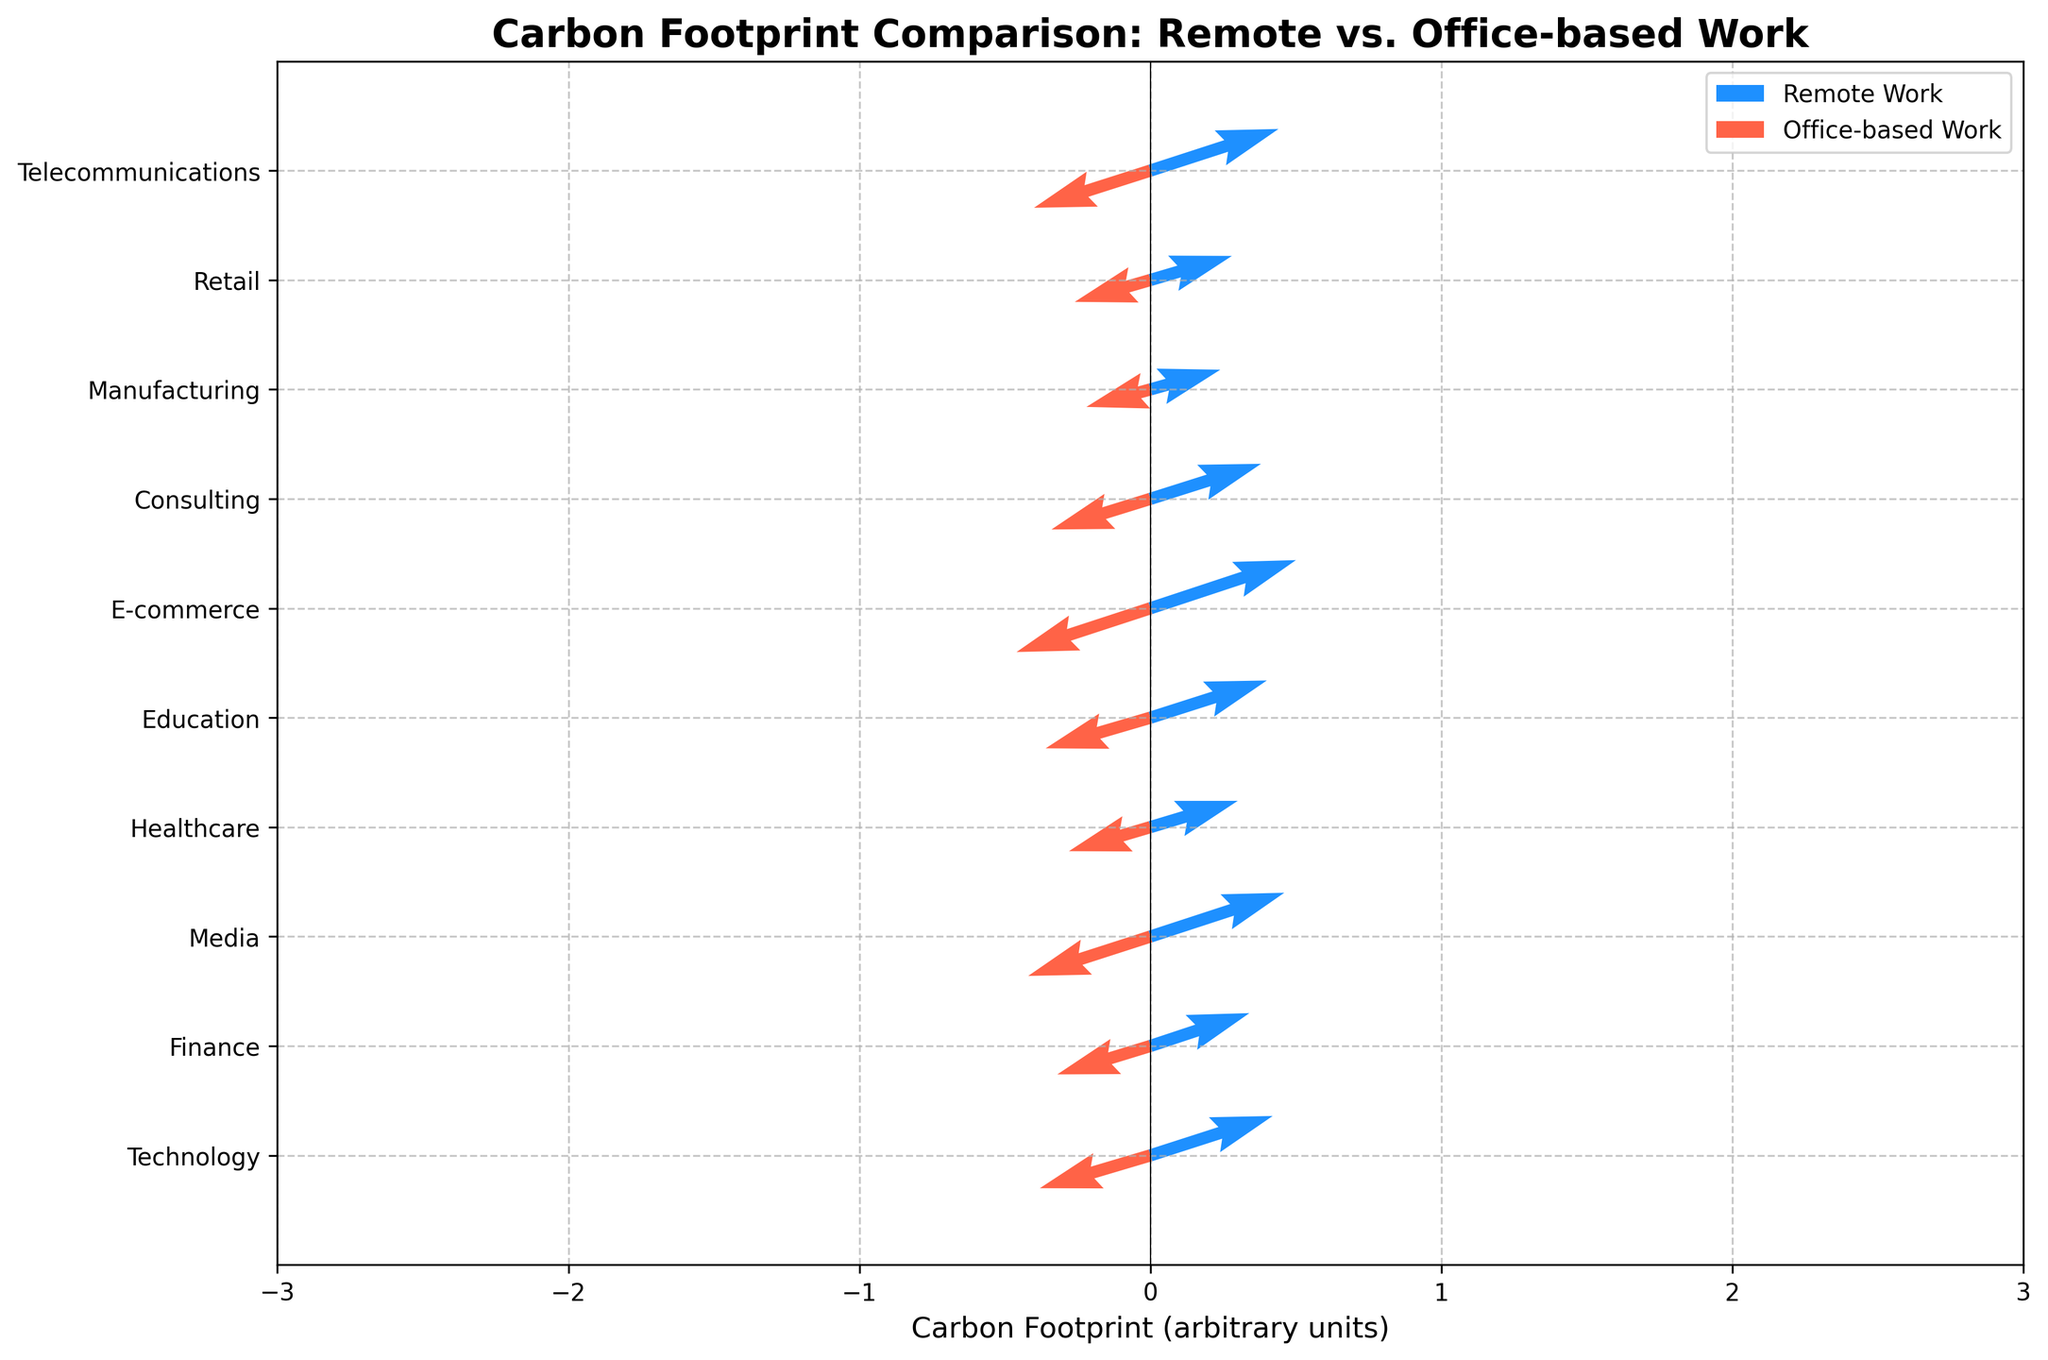What does the title of the figure indicate? The title of the figure reads "Carbon Footprint Comparison: Remote vs. Office-based Work," which indicates that the figure compares the carbon footprint associated with remote work versus office-based work across various industries.
Answer: Carbon Footprint Comparison: Remote vs. Office-based Work How can you distinguish between the vectors for remote work and office-based work? The vectors for remote work are colored blue, while the vectors for office-based work are colored red.
Answer: Blue is for remote work and red is for office-based work Which industry has the highest carbon footprint for remote work? By observing the lengths of the blue vectors, the E-commerce industry has the highest carbon footprint for remote work, as its vector extends furthest to the right and upwards.
Answer: E-commerce What are the coordinates for the remote work vector in the Technology industry? The coordinates for the remote work vector in the Technology industry are indicated at (2.1, 1.8) on the quiver plot.
Answer: (2.1, 1.8) Which industries show a higher carbon footprint reduction when switching from office-based work to remote work? By comparing the lengths and directions of the red and blue vectors, E-commerce and Media industries show significant reductions as their red vectors are much longer than their blue vectors in the negative direction.
Answer: E-commerce and Media What is the average Y-coordinate for the office-based work vectors across all industries? Sum the Y-coordinates of the office-based work vectors (−1.5, −1.3, −1.8, −1.1, −1.4, −2.0, −1.4, −0.8, −1.0, −1.7) which is −15.0, then divide by the number of industries which is 10.
Answer: −1.5 Which industry shows the smallest difference in carbon footprint between remote and office-based work? The Manufacturing industry shows the smallest difference as evidenced by the similar lengths and directions of the blue and red vectors, (1.2, 0.9) for remote and (−1.1, −0.8) for office.
Answer: Manufacturing How do the Education and Finance industries compare in terms of remote work carbon footprints? The remote work vector in the Education industry (2.0, 1.7) is longer and extends further than the remote work vector in the Finance industry (1.7, 1.5), indicating a higher carbon footprint.
Answer: Education has a higher remote work carbon footprint What is the range of the X-coordinates for the office-based work vectors across all industries? The X-coordinates for the office-based work vectors range from −1.1 (Manufacturing) to −2.3 (E-commerce). Therefore, the range is from −2.3 to −1.1.
Answer: From −2.3 to −1.1 Can you identify an outlier industry in terms of carbon reduction from remote work to office-based work? The E-commerce industry stands out as an outlier with the largest carbon footprint reduction, shown by the longest decrease in vector length from remote work (2.5, 2.2) to office-based work (−2.3, −2.0).
Answer: E-commerce 